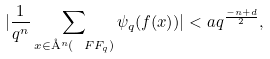Convert formula to latex. <formula><loc_0><loc_0><loc_500><loc_500>| \frac { 1 } { q ^ { n } } \sum _ { x \in \AA ^ { n } ( \ F F _ { q } ) } \psi _ { q } ( f ( x ) ) | < a q ^ { \frac { - n + d } { 2 } } ,</formula> 